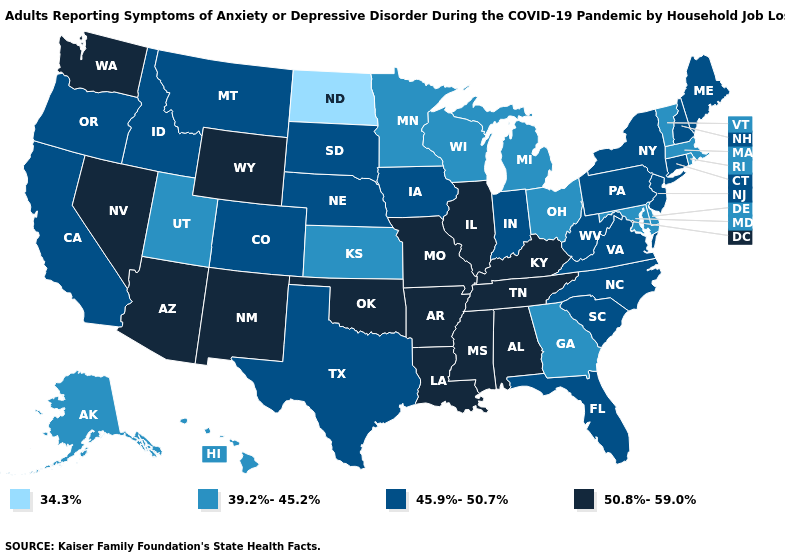What is the highest value in the South ?
Short answer required. 50.8%-59.0%. Name the states that have a value in the range 34.3%?
Write a very short answer. North Dakota. What is the value of Minnesota?
Concise answer only. 39.2%-45.2%. Does New Mexico have a higher value than Mississippi?
Answer briefly. No. Which states have the highest value in the USA?
Give a very brief answer. Alabama, Arizona, Arkansas, Illinois, Kentucky, Louisiana, Mississippi, Missouri, Nevada, New Mexico, Oklahoma, Tennessee, Washington, Wyoming. What is the value of Alabama?
Write a very short answer. 50.8%-59.0%. Name the states that have a value in the range 39.2%-45.2%?
Concise answer only. Alaska, Delaware, Georgia, Hawaii, Kansas, Maryland, Massachusetts, Michigan, Minnesota, Ohio, Rhode Island, Utah, Vermont, Wisconsin. What is the lowest value in states that border Montana?
Give a very brief answer. 34.3%. Among the states that border Massachusetts , does Rhode Island have the highest value?
Keep it brief. No. Which states have the lowest value in the USA?
Answer briefly. North Dakota. Name the states that have a value in the range 45.9%-50.7%?
Keep it brief. California, Colorado, Connecticut, Florida, Idaho, Indiana, Iowa, Maine, Montana, Nebraska, New Hampshire, New Jersey, New York, North Carolina, Oregon, Pennsylvania, South Carolina, South Dakota, Texas, Virginia, West Virginia. Name the states that have a value in the range 34.3%?
Answer briefly. North Dakota. What is the value of Wisconsin?
Give a very brief answer. 39.2%-45.2%. Does the first symbol in the legend represent the smallest category?
Concise answer only. Yes. What is the highest value in the South ?
Give a very brief answer. 50.8%-59.0%. 